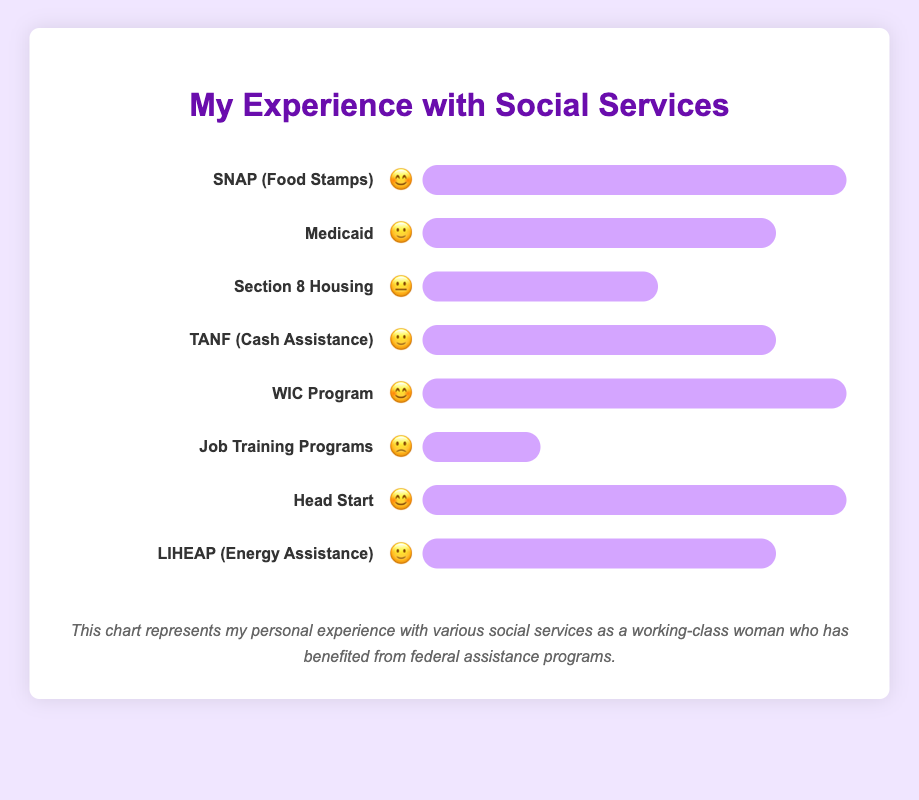Which service has the highest satisfaction rating? The service with the highest satisfaction rating is denoted by the emoji "😊", which is used for SNAP (Food Stamps), WIC Program, and Head Start.
Answer: SNAP (Food Stamps), WIC Program, and Head Start Which service has the lowest satisfaction rating? The service with the lowest satisfaction rating is represented by the emoji "🙁". This emoji is used for the Job Training Programs.
Answer: Job Training Programs What is the overall satisfaction trend for healthcare-related services? The healthcare-related services in the chart are Medicaid and WIC Program. Medicaid is rated "🙂", while the WIC Program is rated "😊". This shows a trend toward moderate to high satisfaction.
Answer: Moderate to high satisfaction How many services have a satisfaction rating of at least "🙂"? The services with a satisfaction rating of "🙂" or higher (🙂 or 😊) include: SNAP (Food Stamps), Medicaid, TANF (Cash Assistance), WIC Program, Head Start, and LIHEAP (Energy Assistance). This totals to 6 services.
Answer: 6 Compare the satisfaction levels between TANF (Cash Assistance) and Section 8 Housing. TANF (Cash Assistance) has a satisfaction rating of "🙂" and Section 8 Housing has a satisfaction rating of "😐". Comparing the two, TANF has a higher satisfaction level than Section 8 Housing.
Answer: TANF (Cash Assistance) Which service related to housing has the lowest satisfaction rating? The service related to housing with the lowest satisfaction rating is Section 8 Housing, which is rated "😐".
Answer: Section 8 Housing How do SNAP (Food Stamps) and Head Start compare in terms of satisfaction? Both SNAP (Food Stamps) and Head Start have a satisfaction rating of "😊". This indicates that they have equal satisfaction levels.
Answer: Same satisfaction level What is the satisfaction rating for LIHEAP (Energy Assistance)? The satisfaction rating for LIHEAP (Energy Assistance) is represented by the emoji "🙂".
Answer: 🙂 Is there a service with a neutral satisfaction level? Yes, the service with a neutral satisfaction level, represented by the emoji "😐", is Section 8 Housing.
Answer: Section 8 Housing 